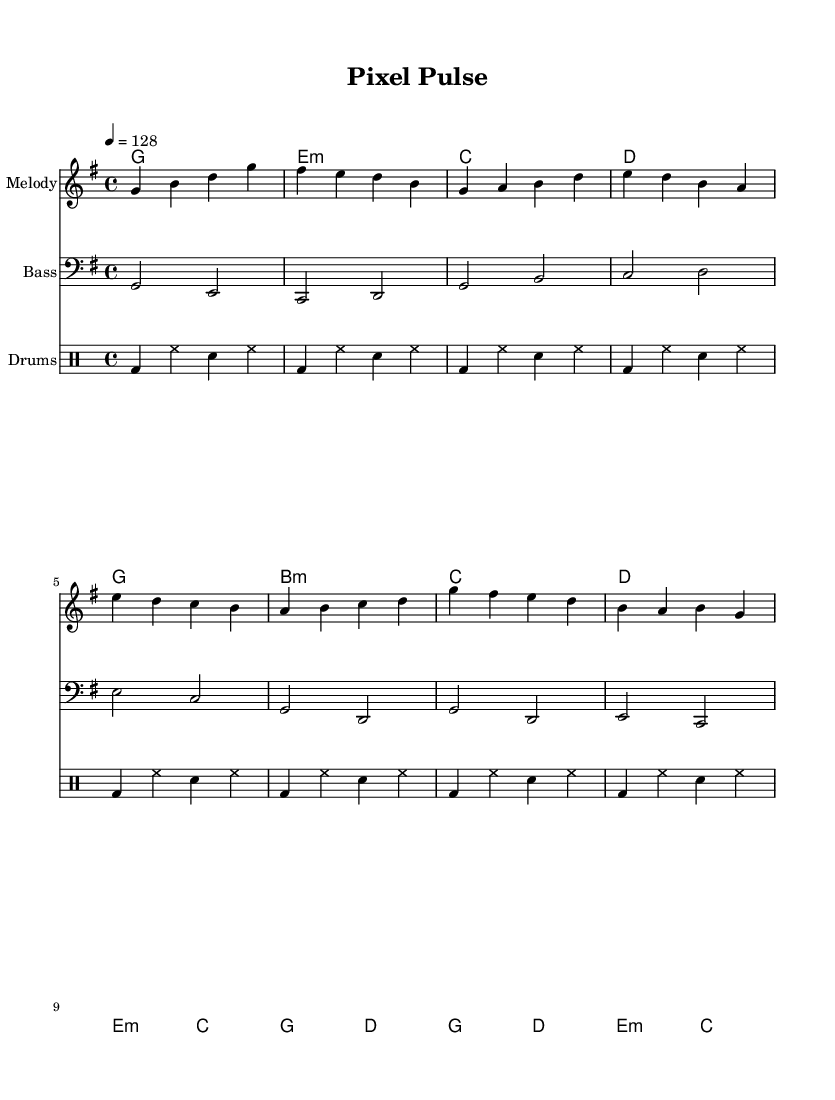what is the key signature of this music? The key signature indicated in the sheet music is G major, which has one sharp (F#). This is determined from the `\key g \major` directive in the global section of the code.
Answer: G major what is the time signature of this music? The time signature presented in the sheet music is 4/4, which means there are four beats in a measure and the quarter note gets one beat. This is found in the `\time 4/4` statement in the global section.
Answer: 4/4 what is the tempo marking of this music? The tempo marking in this piece is set at a speed of 128 beats per minute (BPM), as indicated by the `\tempo 4 = 128` directive.
Answer: 128 how many measures are present in the chorus section? The chorus section contains four measures, which can be counted from examining the measures defined by the melody and chord parts. Each line of the chorus includes four distinct bars.
Answer: 4 what type of drum pattern is used throughout the piece? The drum pattern used in the music is a simplified four-beat pattern alternating between bass drum and hi-hat, with snare hits added. This is determined by analyzing the repeated `bd`, `hh`, and `sn` notations in the drum section.
Answer: Simplified how does the bassline relate to the melody in the verse? The bassline in the verse provides a foundational harmonic structure by playing root notes that align with the melody notes. This relationship is observed where both parts play in synchronization, enhancing the overall texture.
Answer: Harmonic structure how does the structure of K-Pop influence the arrangement of this piece? The arrangement follows a typical K-Pop structure, including an intro, verse, pre-chorus, and chorus, all designed to create a catchy and memorable experience, which is characteristic of K-Pop music. This is evidenced by the labelled sections in the melody and chord parts.
Answer: Catchy 